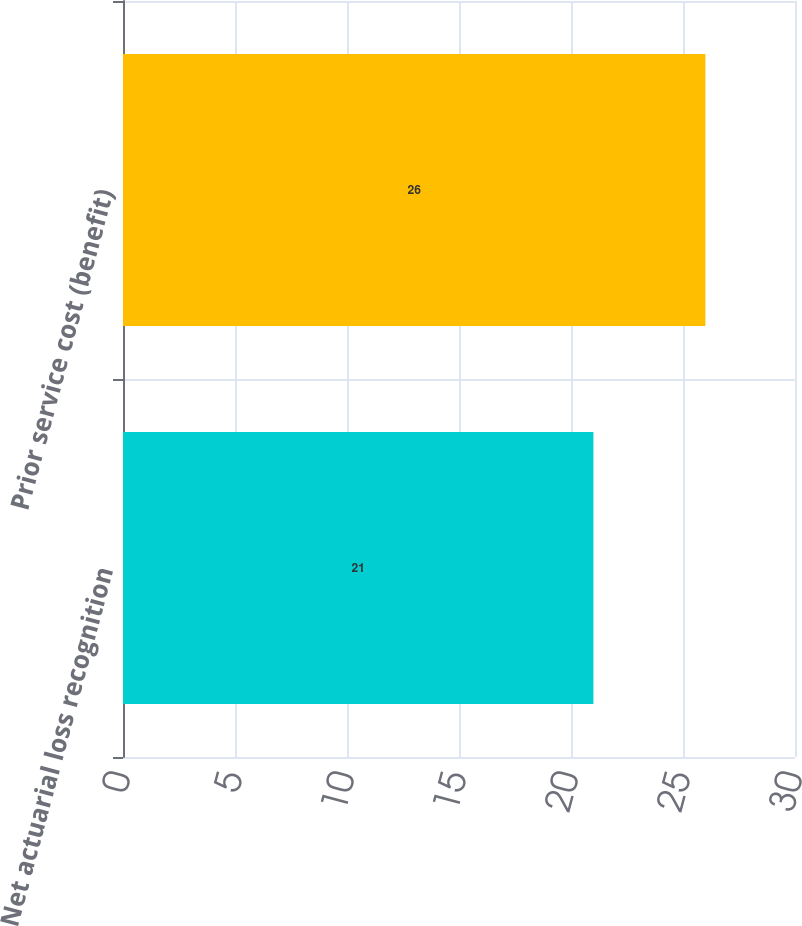<chart> <loc_0><loc_0><loc_500><loc_500><bar_chart><fcel>Net actuarial loss recognition<fcel>Prior service cost (benefit)<nl><fcel>21<fcel>26<nl></chart> 